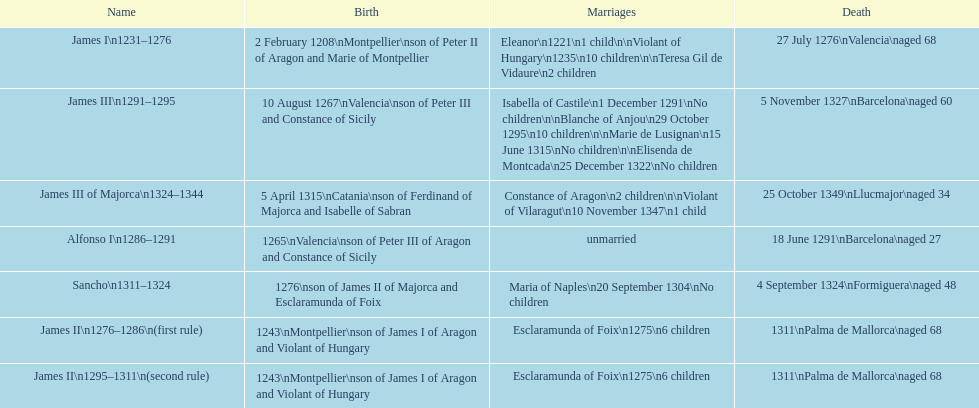Which two sovereigns had no kids? Alfonso I, Sancho. 